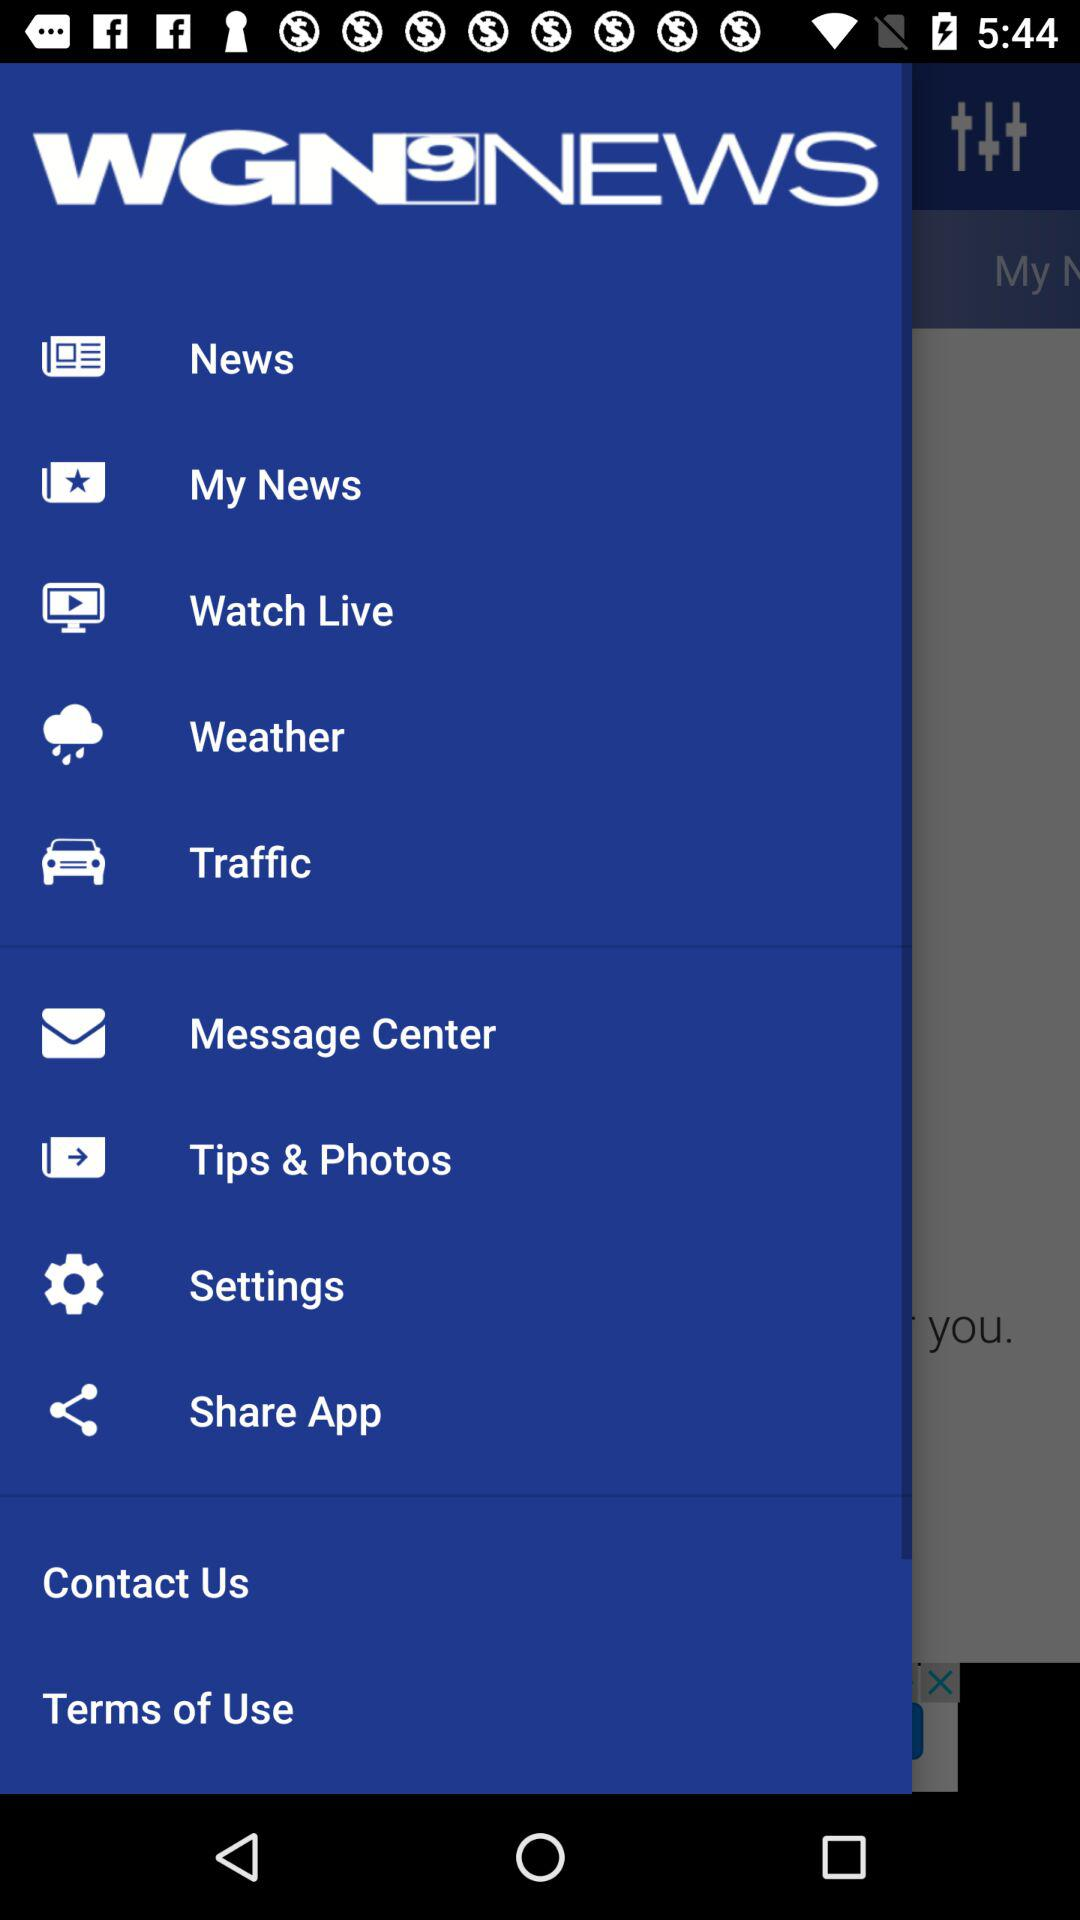What is the status of push notifications? The status is on. 